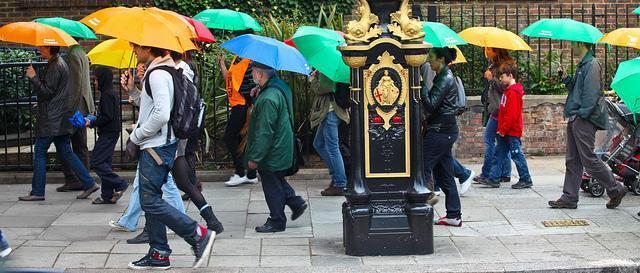How many red umbrellas are there?
Give a very brief answer. 2. How many umbrellas are visible?
Give a very brief answer. 3. How many people are in the photo?
Give a very brief answer. 12. 